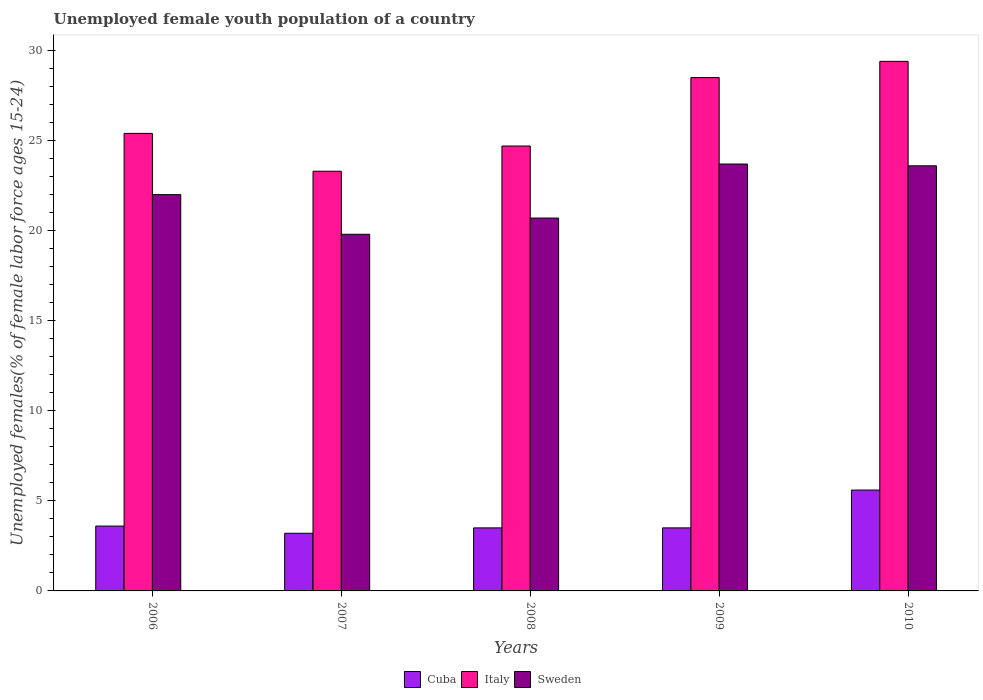How many different coloured bars are there?
Your response must be concise. 3. How many groups of bars are there?
Your response must be concise. 5. Are the number of bars per tick equal to the number of legend labels?
Your response must be concise. Yes. In how many cases, is the number of bars for a given year not equal to the number of legend labels?
Offer a terse response. 0. What is the percentage of unemployed female youth population in Sweden in 2009?
Ensure brevity in your answer.  23.7. Across all years, what is the maximum percentage of unemployed female youth population in Sweden?
Offer a very short reply. 23.7. Across all years, what is the minimum percentage of unemployed female youth population in Cuba?
Provide a short and direct response. 3.2. In which year was the percentage of unemployed female youth population in Sweden maximum?
Your response must be concise. 2009. What is the total percentage of unemployed female youth population in Cuba in the graph?
Give a very brief answer. 19.4. What is the difference between the percentage of unemployed female youth population in Sweden in 2008 and that in 2009?
Your answer should be very brief. -3. What is the difference between the percentage of unemployed female youth population in Cuba in 2008 and the percentage of unemployed female youth population in Italy in 2006?
Make the answer very short. -21.9. What is the average percentage of unemployed female youth population in Sweden per year?
Make the answer very short. 21.96. In the year 2006, what is the difference between the percentage of unemployed female youth population in Cuba and percentage of unemployed female youth population in Italy?
Provide a short and direct response. -21.8. What is the ratio of the percentage of unemployed female youth population in Italy in 2008 to that in 2010?
Your answer should be very brief. 0.84. Is the percentage of unemployed female youth population in Sweden in 2007 less than that in 2009?
Your answer should be compact. Yes. What is the difference between the highest and the second highest percentage of unemployed female youth population in Italy?
Offer a very short reply. 0.9. What is the difference between the highest and the lowest percentage of unemployed female youth population in Cuba?
Ensure brevity in your answer.  2.4. In how many years, is the percentage of unemployed female youth population in Sweden greater than the average percentage of unemployed female youth population in Sweden taken over all years?
Your answer should be compact. 3. Is the sum of the percentage of unemployed female youth population in Cuba in 2006 and 2009 greater than the maximum percentage of unemployed female youth population in Italy across all years?
Make the answer very short. No. What does the 3rd bar from the right in 2007 represents?
Your answer should be very brief. Cuba. How many years are there in the graph?
Offer a terse response. 5. What is the difference between two consecutive major ticks on the Y-axis?
Give a very brief answer. 5. Does the graph contain grids?
Your answer should be very brief. No. Where does the legend appear in the graph?
Your answer should be very brief. Bottom center. How are the legend labels stacked?
Keep it short and to the point. Horizontal. What is the title of the graph?
Your response must be concise. Unemployed female youth population of a country. What is the label or title of the X-axis?
Keep it short and to the point. Years. What is the label or title of the Y-axis?
Give a very brief answer. Unemployed females(% of female labor force ages 15-24). What is the Unemployed females(% of female labor force ages 15-24) of Cuba in 2006?
Provide a succinct answer. 3.6. What is the Unemployed females(% of female labor force ages 15-24) of Italy in 2006?
Provide a succinct answer. 25.4. What is the Unemployed females(% of female labor force ages 15-24) in Sweden in 2006?
Provide a short and direct response. 22. What is the Unemployed females(% of female labor force ages 15-24) of Cuba in 2007?
Offer a terse response. 3.2. What is the Unemployed females(% of female labor force ages 15-24) in Italy in 2007?
Provide a short and direct response. 23.3. What is the Unemployed females(% of female labor force ages 15-24) of Sweden in 2007?
Your response must be concise. 19.8. What is the Unemployed females(% of female labor force ages 15-24) of Italy in 2008?
Your response must be concise. 24.7. What is the Unemployed females(% of female labor force ages 15-24) of Sweden in 2008?
Make the answer very short. 20.7. What is the Unemployed females(% of female labor force ages 15-24) in Cuba in 2009?
Your answer should be very brief. 3.5. What is the Unemployed females(% of female labor force ages 15-24) of Sweden in 2009?
Offer a terse response. 23.7. What is the Unemployed females(% of female labor force ages 15-24) of Cuba in 2010?
Keep it short and to the point. 5.6. What is the Unemployed females(% of female labor force ages 15-24) in Italy in 2010?
Provide a succinct answer. 29.4. What is the Unemployed females(% of female labor force ages 15-24) in Sweden in 2010?
Provide a succinct answer. 23.6. Across all years, what is the maximum Unemployed females(% of female labor force ages 15-24) of Cuba?
Offer a very short reply. 5.6. Across all years, what is the maximum Unemployed females(% of female labor force ages 15-24) in Italy?
Your answer should be compact. 29.4. Across all years, what is the maximum Unemployed females(% of female labor force ages 15-24) in Sweden?
Keep it short and to the point. 23.7. Across all years, what is the minimum Unemployed females(% of female labor force ages 15-24) of Cuba?
Keep it short and to the point. 3.2. Across all years, what is the minimum Unemployed females(% of female labor force ages 15-24) in Italy?
Ensure brevity in your answer.  23.3. Across all years, what is the minimum Unemployed females(% of female labor force ages 15-24) in Sweden?
Your answer should be very brief. 19.8. What is the total Unemployed females(% of female labor force ages 15-24) of Cuba in the graph?
Give a very brief answer. 19.4. What is the total Unemployed females(% of female labor force ages 15-24) of Italy in the graph?
Offer a very short reply. 131.3. What is the total Unemployed females(% of female labor force ages 15-24) of Sweden in the graph?
Offer a very short reply. 109.8. What is the difference between the Unemployed females(% of female labor force ages 15-24) of Cuba in 2006 and that in 2007?
Offer a terse response. 0.4. What is the difference between the Unemployed females(% of female labor force ages 15-24) of Sweden in 2006 and that in 2008?
Offer a terse response. 1.3. What is the difference between the Unemployed females(% of female labor force ages 15-24) of Cuba in 2006 and that in 2009?
Provide a short and direct response. 0.1. What is the difference between the Unemployed females(% of female labor force ages 15-24) of Italy in 2006 and that in 2009?
Your response must be concise. -3.1. What is the difference between the Unemployed females(% of female labor force ages 15-24) of Sweden in 2006 and that in 2009?
Your response must be concise. -1.7. What is the difference between the Unemployed females(% of female labor force ages 15-24) in Cuba in 2006 and that in 2010?
Ensure brevity in your answer.  -2. What is the difference between the Unemployed females(% of female labor force ages 15-24) in Cuba in 2007 and that in 2008?
Ensure brevity in your answer.  -0.3. What is the difference between the Unemployed females(% of female labor force ages 15-24) in Italy in 2007 and that in 2008?
Keep it short and to the point. -1.4. What is the difference between the Unemployed females(% of female labor force ages 15-24) in Cuba in 2007 and that in 2009?
Offer a terse response. -0.3. What is the difference between the Unemployed females(% of female labor force ages 15-24) in Sweden in 2007 and that in 2009?
Make the answer very short. -3.9. What is the difference between the Unemployed females(% of female labor force ages 15-24) of Italy in 2008 and that in 2009?
Make the answer very short. -3.8. What is the difference between the Unemployed females(% of female labor force ages 15-24) in Cuba in 2008 and that in 2010?
Provide a short and direct response. -2.1. What is the difference between the Unemployed females(% of female labor force ages 15-24) of Italy in 2008 and that in 2010?
Ensure brevity in your answer.  -4.7. What is the difference between the Unemployed females(% of female labor force ages 15-24) in Sweden in 2008 and that in 2010?
Provide a succinct answer. -2.9. What is the difference between the Unemployed females(% of female labor force ages 15-24) in Italy in 2009 and that in 2010?
Offer a very short reply. -0.9. What is the difference between the Unemployed females(% of female labor force ages 15-24) of Cuba in 2006 and the Unemployed females(% of female labor force ages 15-24) of Italy in 2007?
Your answer should be compact. -19.7. What is the difference between the Unemployed females(% of female labor force ages 15-24) in Cuba in 2006 and the Unemployed females(% of female labor force ages 15-24) in Sweden in 2007?
Offer a terse response. -16.2. What is the difference between the Unemployed females(% of female labor force ages 15-24) in Italy in 2006 and the Unemployed females(% of female labor force ages 15-24) in Sweden in 2007?
Keep it short and to the point. 5.6. What is the difference between the Unemployed females(% of female labor force ages 15-24) of Cuba in 2006 and the Unemployed females(% of female labor force ages 15-24) of Italy in 2008?
Provide a succinct answer. -21.1. What is the difference between the Unemployed females(% of female labor force ages 15-24) in Cuba in 2006 and the Unemployed females(% of female labor force ages 15-24) in Sweden in 2008?
Make the answer very short. -17.1. What is the difference between the Unemployed females(% of female labor force ages 15-24) of Italy in 2006 and the Unemployed females(% of female labor force ages 15-24) of Sweden in 2008?
Your answer should be very brief. 4.7. What is the difference between the Unemployed females(% of female labor force ages 15-24) in Cuba in 2006 and the Unemployed females(% of female labor force ages 15-24) in Italy in 2009?
Provide a short and direct response. -24.9. What is the difference between the Unemployed females(% of female labor force ages 15-24) of Cuba in 2006 and the Unemployed females(% of female labor force ages 15-24) of Sweden in 2009?
Keep it short and to the point. -20.1. What is the difference between the Unemployed females(% of female labor force ages 15-24) in Cuba in 2006 and the Unemployed females(% of female labor force ages 15-24) in Italy in 2010?
Your answer should be compact. -25.8. What is the difference between the Unemployed females(% of female labor force ages 15-24) of Cuba in 2007 and the Unemployed females(% of female labor force ages 15-24) of Italy in 2008?
Provide a succinct answer. -21.5. What is the difference between the Unemployed females(% of female labor force ages 15-24) in Cuba in 2007 and the Unemployed females(% of female labor force ages 15-24) in Sweden in 2008?
Provide a succinct answer. -17.5. What is the difference between the Unemployed females(% of female labor force ages 15-24) in Italy in 2007 and the Unemployed females(% of female labor force ages 15-24) in Sweden in 2008?
Make the answer very short. 2.6. What is the difference between the Unemployed females(% of female labor force ages 15-24) in Cuba in 2007 and the Unemployed females(% of female labor force ages 15-24) in Italy in 2009?
Make the answer very short. -25.3. What is the difference between the Unemployed females(% of female labor force ages 15-24) in Cuba in 2007 and the Unemployed females(% of female labor force ages 15-24) in Sweden in 2009?
Offer a very short reply. -20.5. What is the difference between the Unemployed females(% of female labor force ages 15-24) in Cuba in 2007 and the Unemployed females(% of female labor force ages 15-24) in Italy in 2010?
Provide a short and direct response. -26.2. What is the difference between the Unemployed females(% of female labor force ages 15-24) of Cuba in 2007 and the Unemployed females(% of female labor force ages 15-24) of Sweden in 2010?
Your answer should be very brief. -20.4. What is the difference between the Unemployed females(% of female labor force ages 15-24) in Italy in 2007 and the Unemployed females(% of female labor force ages 15-24) in Sweden in 2010?
Provide a succinct answer. -0.3. What is the difference between the Unemployed females(% of female labor force ages 15-24) in Cuba in 2008 and the Unemployed females(% of female labor force ages 15-24) in Sweden in 2009?
Your answer should be very brief. -20.2. What is the difference between the Unemployed females(% of female labor force ages 15-24) in Italy in 2008 and the Unemployed females(% of female labor force ages 15-24) in Sweden in 2009?
Provide a succinct answer. 1. What is the difference between the Unemployed females(% of female labor force ages 15-24) in Cuba in 2008 and the Unemployed females(% of female labor force ages 15-24) in Italy in 2010?
Ensure brevity in your answer.  -25.9. What is the difference between the Unemployed females(% of female labor force ages 15-24) of Cuba in 2008 and the Unemployed females(% of female labor force ages 15-24) of Sweden in 2010?
Offer a terse response. -20.1. What is the difference between the Unemployed females(% of female labor force ages 15-24) in Cuba in 2009 and the Unemployed females(% of female labor force ages 15-24) in Italy in 2010?
Offer a very short reply. -25.9. What is the difference between the Unemployed females(% of female labor force ages 15-24) of Cuba in 2009 and the Unemployed females(% of female labor force ages 15-24) of Sweden in 2010?
Offer a terse response. -20.1. What is the difference between the Unemployed females(% of female labor force ages 15-24) in Italy in 2009 and the Unemployed females(% of female labor force ages 15-24) in Sweden in 2010?
Provide a short and direct response. 4.9. What is the average Unemployed females(% of female labor force ages 15-24) in Cuba per year?
Provide a succinct answer. 3.88. What is the average Unemployed females(% of female labor force ages 15-24) of Italy per year?
Provide a short and direct response. 26.26. What is the average Unemployed females(% of female labor force ages 15-24) in Sweden per year?
Provide a short and direct response. 21.96. In the year 2006, what is the difference between the Unemployed females(% of female labor force ages 15-24) in Cuba and Unemployed females(% of female labor force ages 15-24) in Italy?
Make the answer very short. -21.8. In the year 2006, what is the difference between the Unemployed females(% of female labor force ages 15-24) of Cuba and Unemployed females(% of female labor force ages 15-24) of Sweden?
Provide a short and direct response. -18.4. In the year 2007, what is the difference between the Unemployed females(% of female labor force ages 15-24) of Cuba and Unemployed females(% of female labor force ages 15-24) of Italy?
Your response must be concise. -20.1. In the year 2007, what is the difference between the Unemployed females(% of female labor force ages 15-24) in Cuba and Unemployed females(% of female labor force ages 15-24) in Sweden?
Provide a short and direct response. -16.6. In the year 2007, what is the difference between the Unemployed females(% of female labor force ages 15-24) in Italy and Unemployed females(% of female labor force ages 15-24) in Sweden?
Offer a terse response. 3.5. In the year 2008, what is the difference between the Unemployed females(% of female labor force ages 15-24) in Cuba and Unemployed females(% of female labor force ages 15-24) in Italy?
Offer a terse response. -21.2. In the year 2008, what is the difference between the Unemployed females(% of female labor force ages 15-24) of Cuba and Unemployed females(% of female labor force ages 15-24) of Sweden?
Make the answer very short. -17.2. In the year 2009, what is the difference between the Unemployed females(% of female labor force ages 15-24) in Cuba and Unemployed females(% of female labor force ages 15-24) in Italy?
Offer a terse response. -25. In the year 2009, what is the difference between the Unemployed females(% of female labor force ages 15-24) of Cuba and Unemployed females(% of female labor force ages 15-24) of Sweden?
Offer a very short reply. -20.2. In the year 2010, what is the difference between the Unemployed females(% of female labor force ages 15-24) of Cuba and Unemployed females(% of female labor force ages 15-24) of Italy?
Make the answer very short. -23.8. What is the ratio of the Unemployed females(% of female labor force ages 15-24) in Italy in 2006 to that in 2007?
Keep it short and to the point. 1.09. What is the ratio of the Unemployed females(% of female labor force ages 15-24) in Cuba in 2006 to that in 2008?
Provide a short and direct response. 1.03. What is the ratio of the Unemployed females(% of female labor force ages 15-24) of Italy in 2006 to that in 2008?
Make the answer very short. 1.03. What is the ratio of the Unemployed females(% of female labor force ages 15-24) in Sweden in 2006 to that in 2008?
Ensure brevity in your answer.  1.06. What is the ratio of the Unemployed females(% of female labor force ages 15-24) of Cuba in 2006 to that in 2009?
Offer a terse response. 1.03. What is the ratio of the Unemployed females(% of female labor force ages 15-24) in Italy in 2006 to that in 2009?
Offer a very short reply. 0.89. What is the ratio of the Unemployed females(% of female labor force ages 15-24) in Sweden in 2006 to that in 2009?
Your answer should be compact. 0.93. What is the ratio of the Unemployed females(% of female labor force ages 15-24) of Cuba in 2006 to that in 2010?
Give a very brief answer. 0.64. What is the ratio of the Unemployed females(% of female labor force ages 15-24) in Italy in 2006 to that in 2010?
Keep it short and to the point. 0.86. What is the ratio of the Unemployed females(% of female labor force ages 15-24) in Sweden in 2006 to that in 2010?
Your answer should be very brief. 0.93. What is the ratio of the Unemployed females(% of female labor force ages 15-24) of Cuba in 2007 to that in 2008?
Your answer should be very brief. 0.91. What is the ratio of the Unemployed females(% of female labor force ages 15-24) in Italy in 2007 to that in 2008?
Offer a very short reply. 0.94. What is the ratio of the Unemployed females(% of female labor force ages 15-24) of Sweden in 2007 to that in 2008?
Make the answer very short. 0.96. What is the ratio of the Unemployed females(% of female labor force ages 15-24) in Cuba in 2007 to that in 2009?
Your response must be concise. 0.91. What is the ratio of the Unemployed females(% of female labor force ages 15-24) of Italy in 2007 to that in 2009?
Keep it short and to the point. 0.82. What is the ratio of the Unemployed females(% of female labor force ages 15-24) of Sweden in 2007 to that in 2009?
Provide a short and direct response. 0.84. What is the ratio of the Unemployed females(% of female labor force ages 15-24) in Italy in 2007 to that in 2010?
Give a very brief answer. 0.79. What is the ratio of the Unemployed females(% of female labor force ages 15-24) in Sweden in 2007 to that in 2010?
Ensure brevity in your answer.  0.84. What is the ratio of the Unemployed females(% of female labor force ages 15-24) in Cuba in 2008 to that in 2009?
Offer a very short reply. 1. What is the ratio of the Unemployed females(% of female labor force ages 15-24) of Italy in 2008 to that in 2009?
Give a very brief answer. 0.87. What is the ratio of the Unemployed females(% of female labor force ages 15-24) of Sweden in 2008 to that in 2009?
Make the answer very short. 0.87. What is the ratio of the Unemployed females(% of female labor force ages 15-24) of Italy in 2008 to that in 2010?
Make the answer very short. 0.84. What is the ratio of the Unemployed females(% of female labor force ages 15-24) in Sweden in 2008 to that in 2010?
Make the answer very short. 0.88. What is the ratio of the Unemployed females(% of female labor force ages 15-24) of Italy in 2009 to that in 2010?
Make the answer very short. 0.97. What is the difference between the highest and the second highest Unemployed females(% of female labor force ages 15-24) of Cuba?
Offer a very short reply. 2. What is the difference between the highest and the second highest Unemployed females(% of female labor force ages 15-24) in Sweden?
Your answer should be compact. 0.1. What is the difference between the highest and the lowest Unemployed females(% of female labor force ages 15-24) in Italy?
Provide a short and direct response. 6.1. What is the difference between the highest and the lowest Unemployed females(% of female labor force ages 15-24) in Sweden?
Your response must be concise. 3.9. 